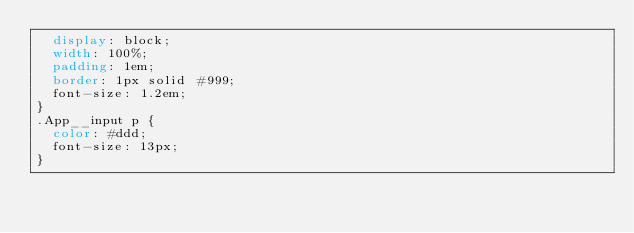<code> <loc_0><loc_0><loc_500><loc_500><_CSS_>  display: block;
  width: 100%;
  padding: 1em;
  border: 1px solid #999;
  font-size: 1.2em;
}
.App__input p {
  color: #ddd;
  font-size: 13px;
}</code> 